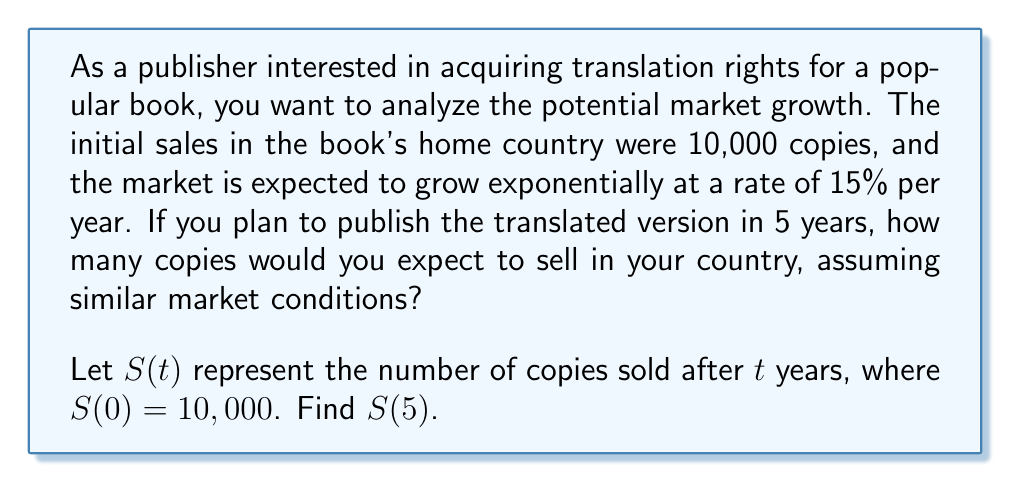Give your solution to this math problem. To solve this problem, we'll use the exponential growth formula:

$$S(t) = S(0) \cdot (1 + r)^t$$

Where:
$S(t)$ is the number of copies sold after $t$ years
$S(0)$ is the initial number of copies sold (10,000)
$r$ is the growth rate (15% = 0.15)
$t$ is the time in years (5)

Step 1: Substitute the given values into the formula
$$S(5) = 10,000 \cdot (1 + 0.15)^5$$

Step 2: Simplify the expression inside the parentheses
$$S(5) = 10,000 \cdot (1.15)^5$$

Step 3: Calculate the exponent
$$(1.15)^5 = 2.0113689$$

Step 4: Multiply by the initial number of copies
$$S(5) = 10,000 \cdot 2.0113689 = 20,113.689$$

Step 5: Round to the nearest whole number (since we can't sell partial books)
$$S(5) \approx 20,114$$
Answer: 20,114 copies 